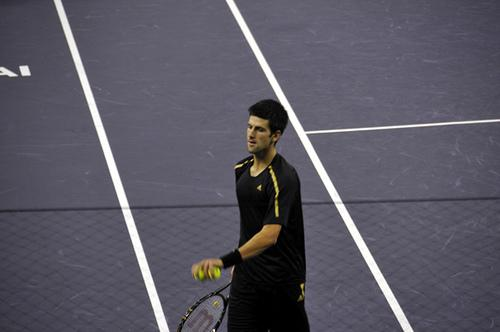What is the person holding in their hands?

Choices:
A) tennis balls
B) straws
C) rocks
D) doves tennis balls 